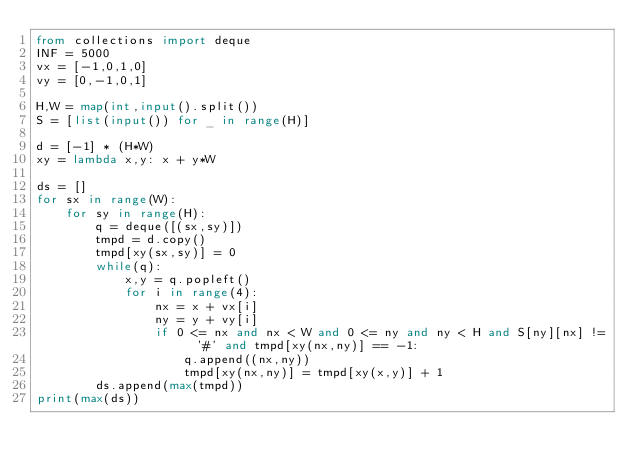<code> <loc_0><loc_0><loc_500><loc_500><_Python_>from collections import deque
INF = 5000
vx = [-1,0,1,0]
vy = [0,-1,0,1]

H,W = map(int,input().split())
S = [list(input()) for _ in range(H)]

d = [-1] * (H*W)
xy = lambda x,y: x + y*W

ds = []
for sx in range(W):
    for sy in range(H):
        q = deque([(sx,sy)])
        tmpd = d.copy()
        tmpd[xy(sx,sy)] = 0
        while(q):
            x,y = q.popleft()
            for i in range(4):
                nx = x + vx[i]
                ny = y + vy[i]
                if 0 <= nx and nx < W and 0 <= ny and ny < H and S[ny][nx] != '#' and tmpd[xy(nx,ny)] == -1:
                    q.append((nx,ny))
                    tmpd[xy(nx,ny)] = tmpd[xy(x,y)] + 1
        ds.append(max(tmpd))
print(max(ds))</code> 